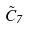<formula> <loc_0><loc_0><loc_500><loc_500>\tilde { C } _ { 7 }</formula> 